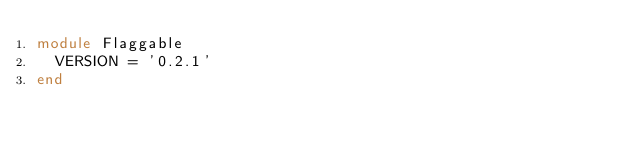Convert code to text. <code><loc_0><loc_0><loc_500><loc_500><_Ruby_>module Flaggable
  VERSION = '0.2.1'
end
</code> 